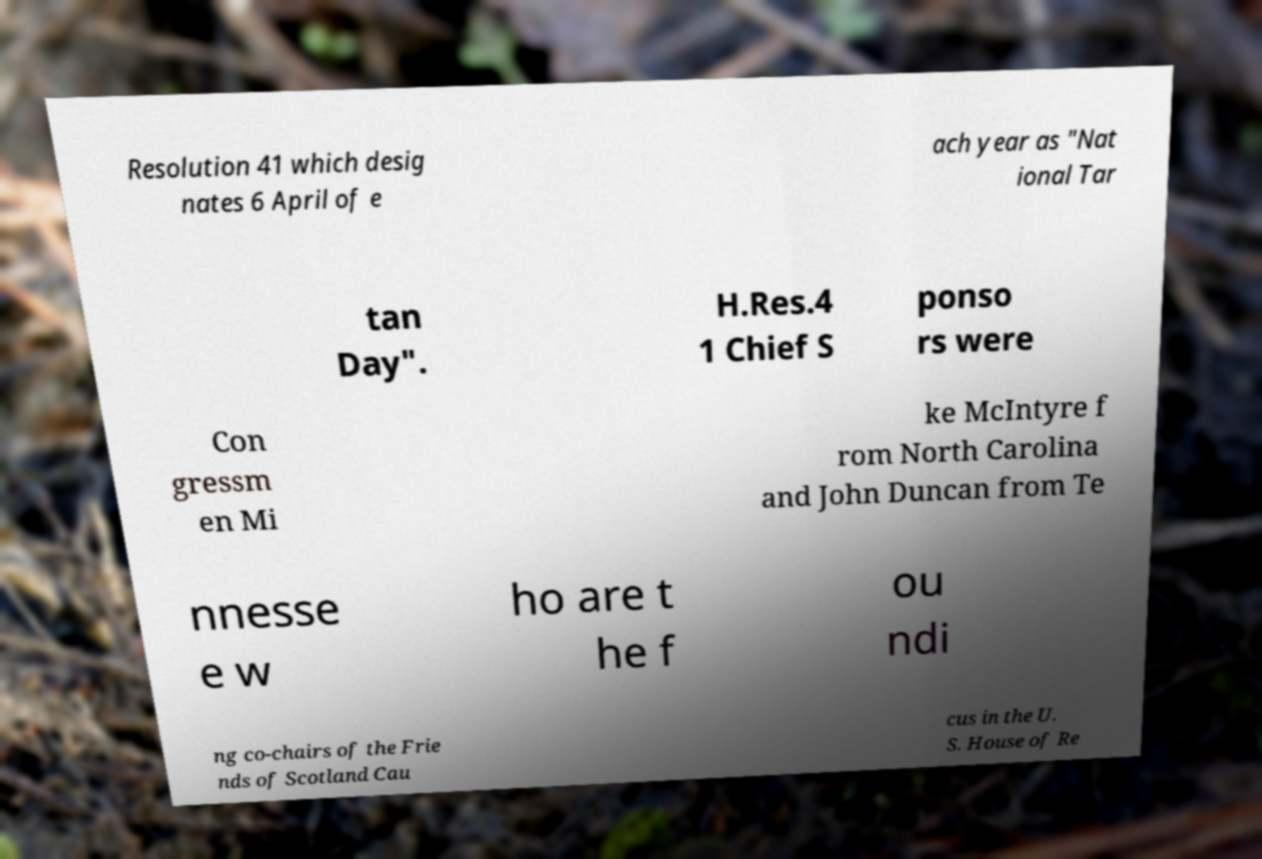Please read and relay the text visible in this image. What does it say? Resolution 41 which desig nates 6 April of e ach year as "Nat ional Tar tan Day". H.Res.4 1 Chief S ponso rs were Con gressm en Mi ke McIntyre f rom North Carolina and John Duncan from Te nnesse e w ho are t he f ou ndi ng co-chairs of the Frie nds of Scotland Cau cus in the U. S. House of Re 